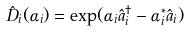<formula> <loc_0><loc_0><loc_500><loc_500>\hat { D } _ { i } ( \alpha _ { i } ) = \exp ( \alpha _ { i } \hat { a } _ { i } ^ { \dag } - \alpha _ { i } ^ { * } \hat { a } _ { i } )</formula> 